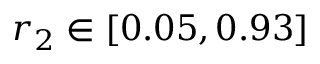<formula> <loc_0><loc_0><loc_500><loc_500>r _ { 2 } \in \left [ 0 . 0 5 , 0 . 9 3 \right ]</formula> 